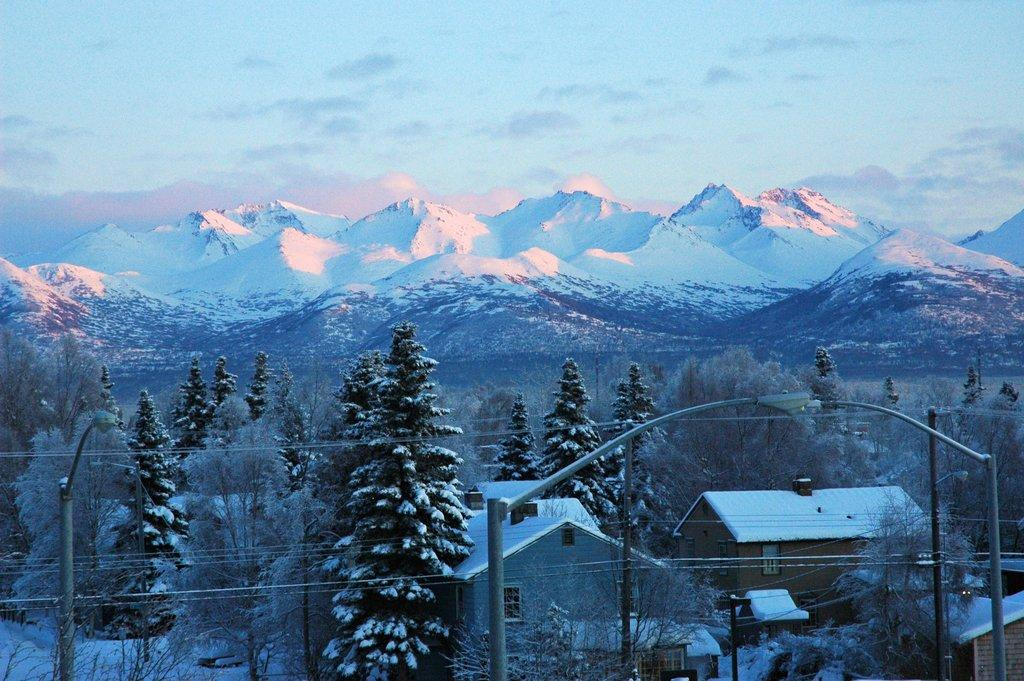What type of houses are visible in the image? There are small shed houses with roof tiles in the image. What can be seen behind the houses? There are trees behind the houses. What is the most prominent feature in the background of the image? There are huge mountains in the background of the image. What is the condition of the mountains? The mountains are covered in snow. What type of straw is used to make the roof tiles of the houses in the image? The image does not provide information about the materials used for the roof tiles of the houses. 